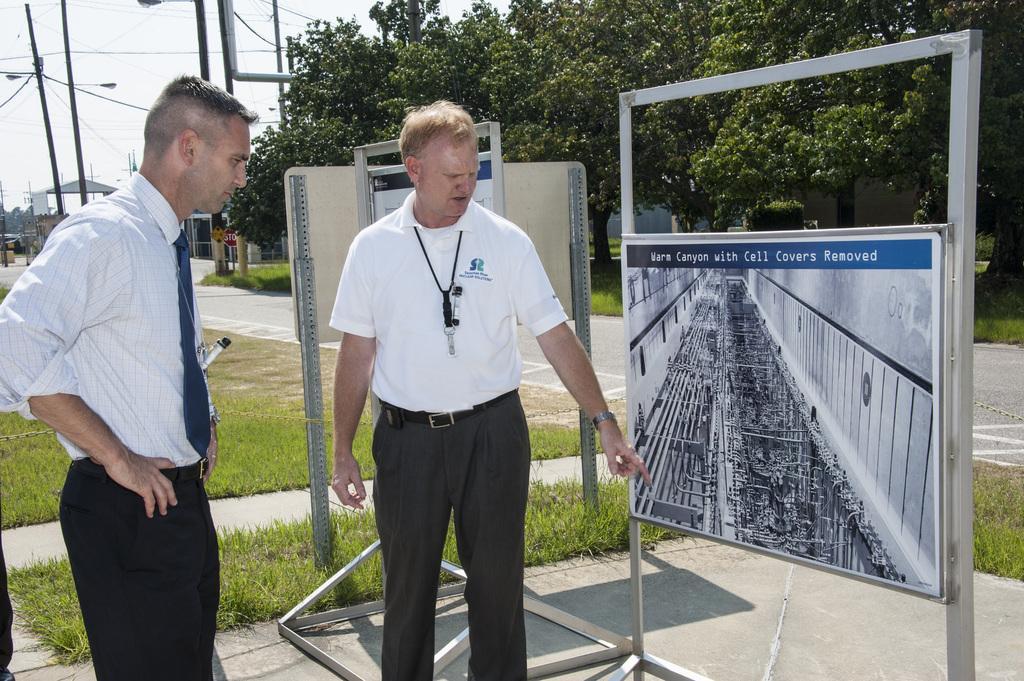Could you give a brief overview of what you see in this image? In this image I can see two men are standing. I can see one of them is wearing shirt, a tie and black pant. On the right side of this image I can see few boards, number of trees, grass, a road and on these boards I can see something is written. In the background I can see number of poles, street lights, wires and few buildings. 